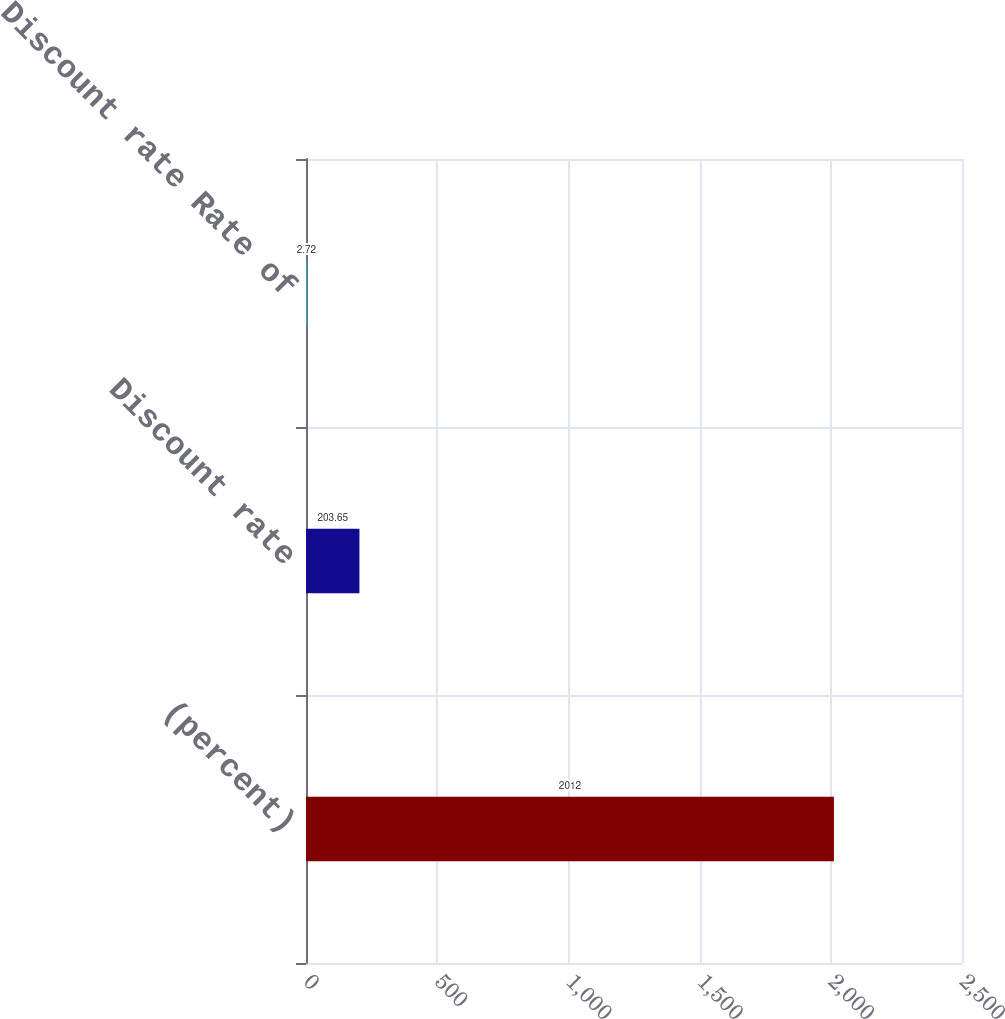Convert chart. <chart><loc_0><loc_0><loc_500><loc_500><bar_chart><fcel>(percent)<fcel>Discount rate<fcel>Discount rate Rate of<nl><fcel>2012<fcel>203.65<fcel>2.72<nl></chart> 